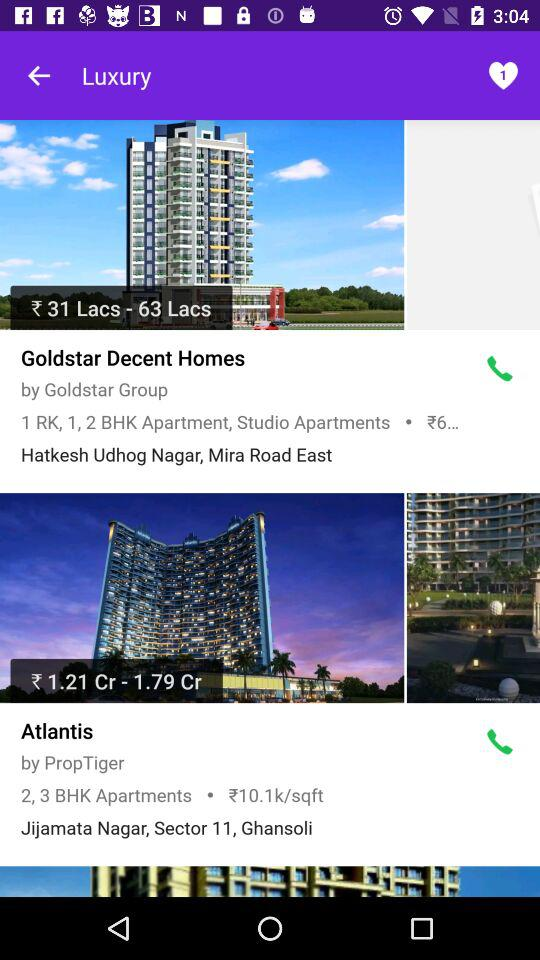What types of apartments are available in "Atlantis"? The types of apartments are "2 BHK" and "3 BHK". 